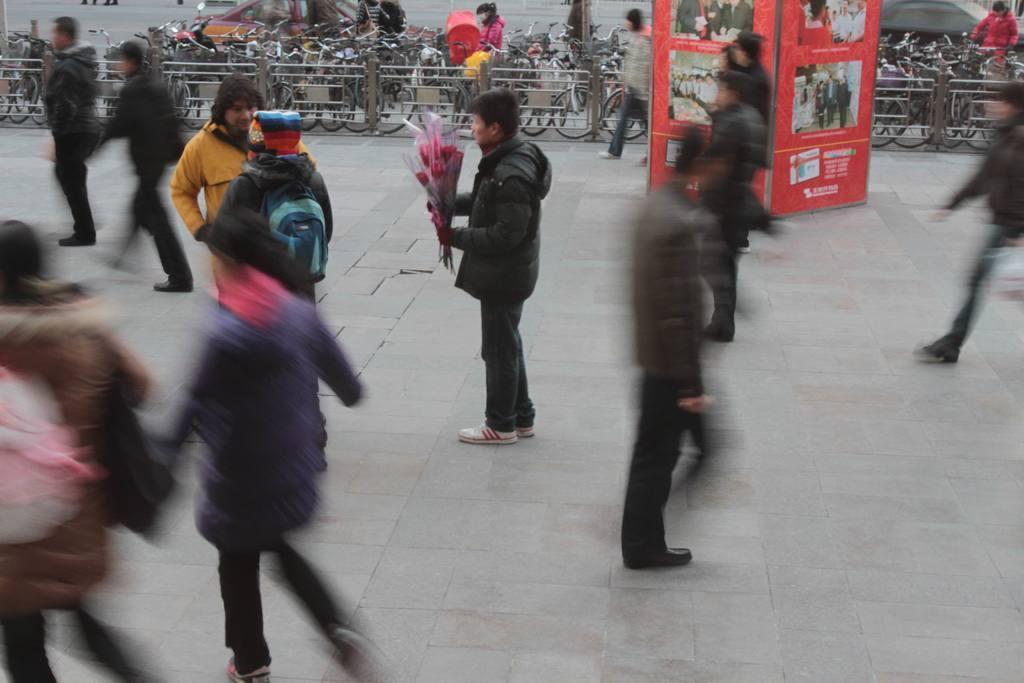Can you describe this image briefly? This is an outside view. In the middle of the image there is a man holding a flower bouquet in the hand and standing facing towards the left side. Around him many people are walking. In the background there is a red color board and a railing. Behind the railing there are many bicycles and also there are few vehicles on the road. 